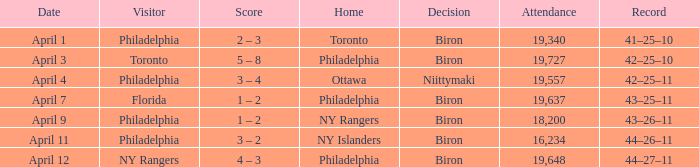Which team visited when the home team was the ny rangers? Philadelphia. 